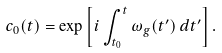<formula> <loc_0><loc_0><loc_500><loc_500>c _ { 0 } ( t ) = \exp \left [ i \int _ { t _ { 0 } } ^ { t } \omega _ { g } ( t ^ { \prime } ) \, d t ^ { \prime } \right ] .</formula> 